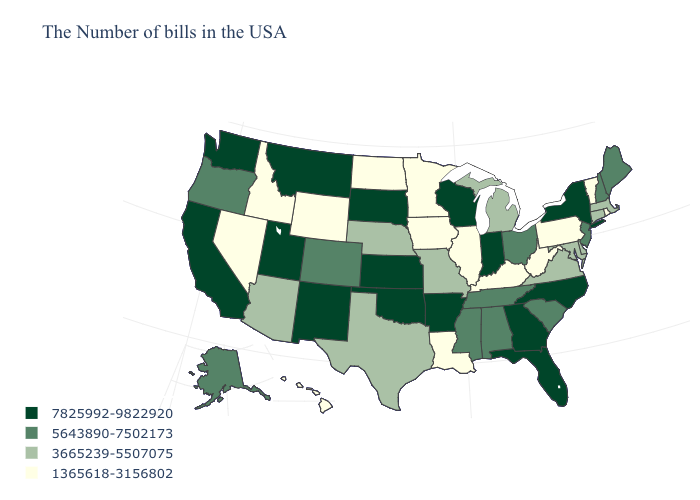What is the value of Wyoming?
Give a very brief answer. 1365618-3156802. What is the value of California?
Give a very brief answer. 7825992-9822920. Name the states that have a value in the range 7825992-9822920?
Answer briefly. New York, North Carolina, Florida, Georgia, Indiana, Wisconsin, Arkansas, Kansas, Oklahoma, South Dakota, New Mexico, Utah, Montana, California, Washington. Name the states that have a value in the range 1365618-3156802?
Keep it brief. Rhode Island, Vermont, Pennsylvania, West Virginia, Kentucky, Illinois, Louisiana, Minnesota, Iowa, North Dakota, Wyoming, Idaho, Nevada, Hawaii. Name the states that have a value in the range 5643890-7502173?
Give a very brief answer. Maine, New Hampshire, New Jersey, South Carolina, Ohio, Alabama, Tennessee, Mississippi, Colorado, Oregon, Alaska. Name the states that have a value in the range 1365618-3156802?
Write a very short answer. Rhode Island, Vermont, Pennsylvania, West Virginia, Kentucky, Illinois, Louisiana, Minnesota, Iowa, North Dakota, Wyoming, Idaho, Nevada, Hawaii. What is the value of Arizona?
Give a very brief answer. 3665239-5507075. What is the value of Iowa?
Short answer required. 1365618-3156802. What is the value of Arkansas?
Short answer required. 7825992-9822920. Name the states that have a value in the range 5643890-7502173?
Write a very short answer. Maine, New Hampshire, New Jersey, South Carolina, Ohio, Alabama, Tennessee, Mississippi, Colorado, Oregon, Alaska. Name the states that have a value in the range 7825992-9822920?
Concise answer only. New York, North Carolina, Florida, Georgia, Indiana, Wisconsin, Arkansas, Kansas, Oklahoma, South Dakota, New Mexico, Utah, Montana, California, Washington. Does Virginia have the lowest value in the South?
Short answer required. No. Among the states that border Maryland , does Pennsylvania have the lowest value?
Concise answer only. Yes. What is the lowest value in the West?
Write a very short answer. 1365618-3156802. Name the states that have a value in the range 5643890-7502173?
Give a very brief answer. Maine, New Hampshire, New Jersey, South Carolina, Ohio, Alabama, Tennessee, Mississippi, Colorado, Oregon, Alaska. 